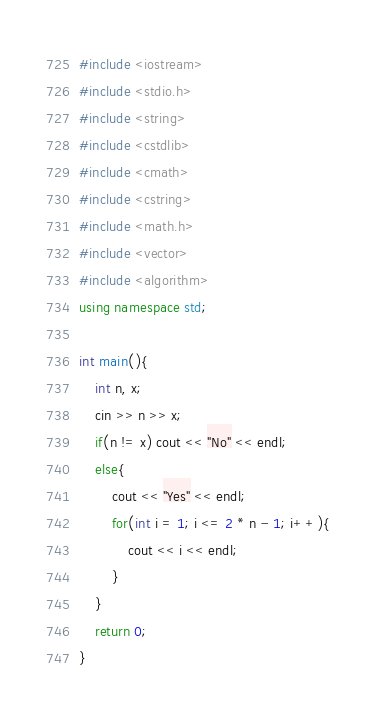<code> <loc_0><loc_0><loc_500><loc_500><_C++_>#include <iostream>
#include <stdio.h>
#include <string>
#include <cstdlib>
#include <cmath>
#include <cstring>
#include <math.h>
#include <vector>
#include <algorithm>
using namespace std;

int main(){
	int n, x;
	cin >> n >> x;
	if(n != x) cout << "No" << endl;
	else{
		cout << "Yes" << endl;
		for(int i = 1; i <= 2 * n - 1; i++){
			cout << i << endl;
		}
	}
	return 0;
}</code> 